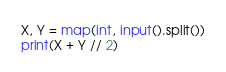Convert code to text. <code><loc_0><loc_0><loc_500><loc_500><_Python_>X, Y = map(int, input().split())
print(X + Y // 2)</code> 